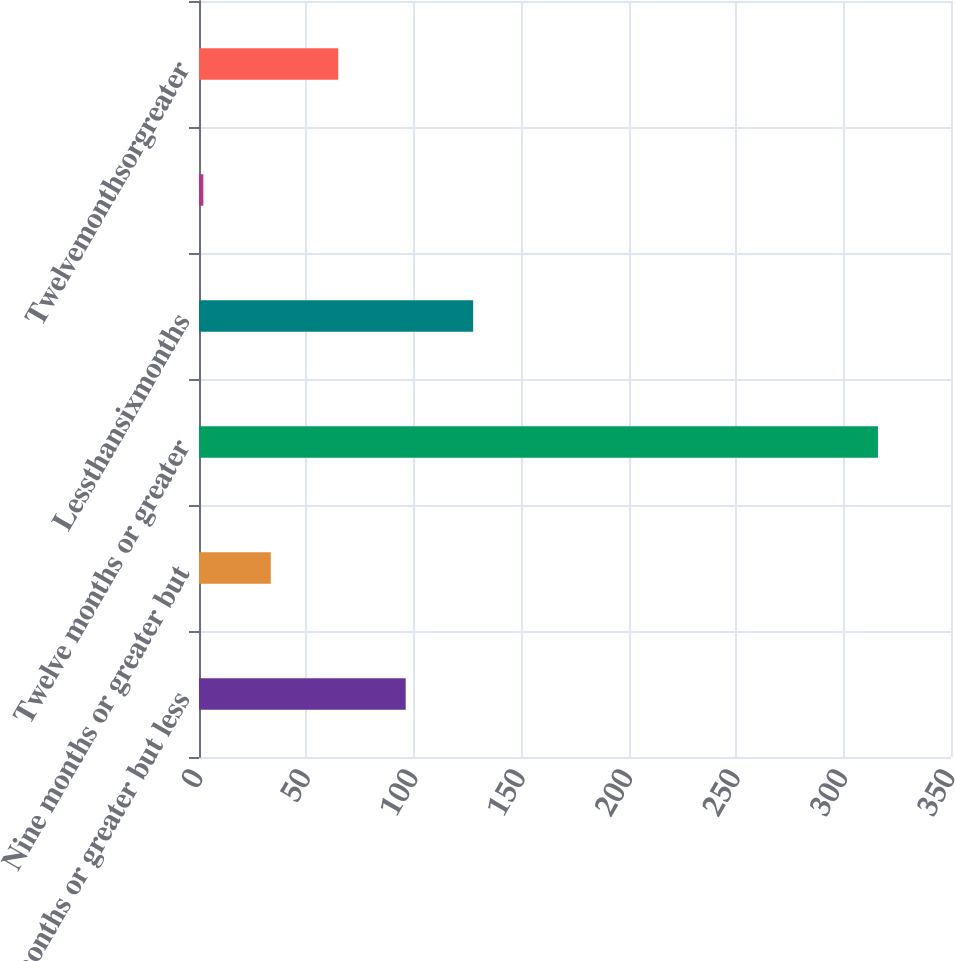Convert chart. <chart><loc_0><loc_0><loc_500><loc_500><bar_chart><fcel>Six months or greater but less<fcel>Nine months or greater but<fcel>Twelve months or greater<fcel>Lessthansixmonths<fcel>Unnamed: 4<fcel>Twelvemonthsorgreater<nl><fcel>96.2<fcel>33.4<fcel>316<fcel>127.6<fcel>2<fcel>64.8<nl></chart> 